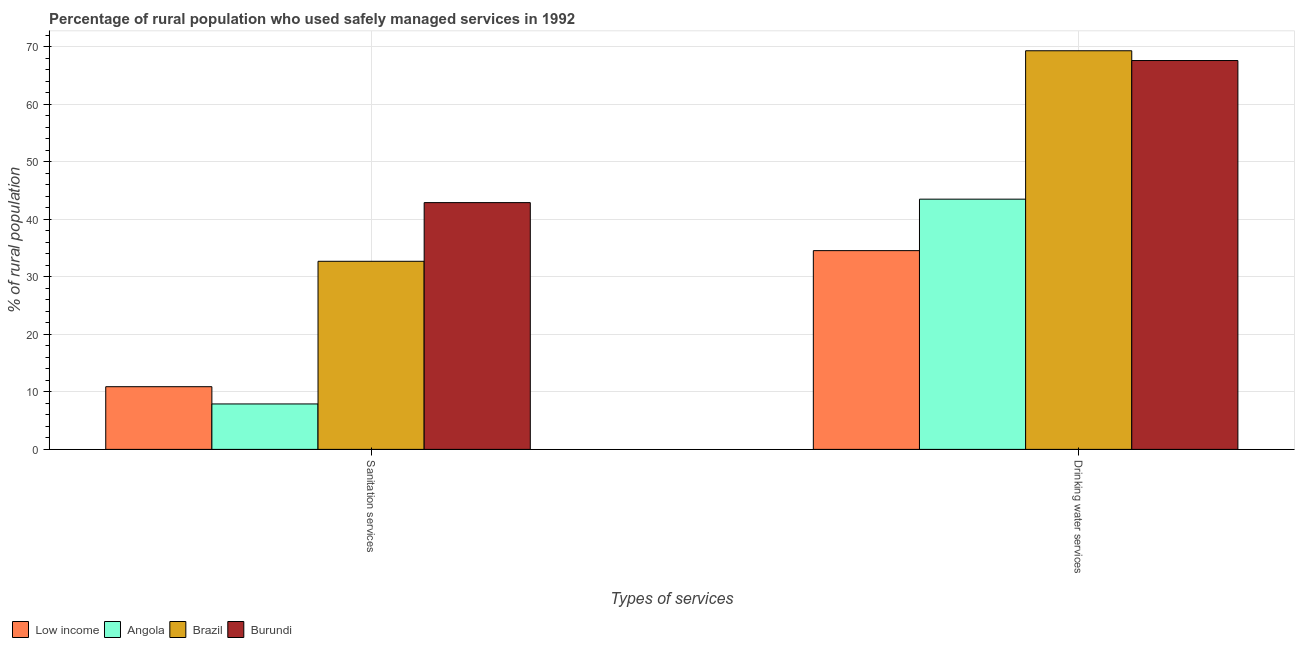How many groups of bars are there?
Your answer should be compact. 2. Are the number of bars on each tick of the X-axis equal?
Offer a terse response. Yes. How many bars are there on the 2nd tick from the left?
Your response must be concise. 4. How many bars are there on the 2nd tick from the right?
Provide a succinct answer. 4. What is the label of the 2nd group of bars from the left?
Make the answer very short. Drinking water services. What is the percentage of rural population who used sanitation services in Burundi?
Your answer should be compact. 42.9. Across all countries, what is the maximum percentage of rural population who used sanitation services?
Provide a short and direct response. 42.9. Across all countries, what is the minimum percentage of rural population who used sanitation services?
Your answer should be compact. 7.9. In which country was the percentage of rural population who used drinking water services maximum?
Give a very brief answer. Brazil. What is the total percentage of rural population who used drinking water services in the graph?
Give a very brief answer. 214.95. What is the difference between the percentage of rural population who used sanitation services in Low income and that in Angola?
Your answer should be very brief. 3. What is the difference between the percentage of rural population who used sanitation services in Low income and the percentage of rural population who used drinking water services in Angola?
Provide a short and direct response. -32.6. What is the average percentage of rural population who used sanitation services per country?
Provide a short and direct response. 23.6. What is the difference between the percentage of rural population who used drinking water services and percentage of rural population who used sanitation services in Low income?
Provide a short and direct response. 23.65. In how many countries, is the percentage of rural population who used sanitation services greater than 48 %?
Keep it short and to the point. 0. What is the ratio of the percentage of rural population who used drinking water services in Low income to that in Burundi?
Keep it short and to the point. 0.51. What does the 2nd bar from the left in Drinking water services represents?
Ensure brevity in your answer.  Angola. What does the 3rd bar from the right in Sanitation services represents?
Your answer should be very brief. Angola. Does the graph contain any zero values?
Make the answer very short. No. Does the graph contain grids?
Make the answer very short. Yes. Where does the legend appear in the graph?
Provide a succinct answer. Bottom left. What is the title of the graph?
Offer a terse response. Percentage of rural population who used safely managed services in 1992. Does "Venezuela" appear as one of the legend labels in the graph?
Your answer should be very brief. No. What is the label or title of the X-axis?
Ensure brevity in your answer.  Types of services. What is the label or title of the Y-axis?
Provide a succinct answer. % of rural population. What is the % of rural population of Low income in Sanitation services?
Offer a terse response. 10.9. What is the % of rural population in Brazil in Sanitation services?
Provide a succinct answer. 32.7. What is the % of rural population of Burundi in Sanitation services?
Provide a succinct answer. 42.9. What is the % of rural population in Low income in Drinking water services?
Your response must be concise. 34.55. What is the % of rural population of Angola in Drinking water services?
Keep it short and to the point. 43.5. What is the % of rural population of Brazil in Drinking water services?
Offer a very short reply. 69.3. What is the % of rural population of Burundi in Drinking water services?
Make the answer very short. 67.6. Across all Types of services, what is the maximum % of rural population of Low income?
Give a very brief answer. 34.55. Across all Types of services, what is the maximum % of rural population in Angola?
Ensure brevity in your answer.  43.5. Across all Types of services, what is the maximum % of rural population of Brazil?
Offer a very short reply. 69.3. Across all Types of services, what is the maximum % of rural population of Burundi?
Your response must be concise. 67.6. Across all Types of services, what is the minimum % of rural population in Low income?
Give a very brief answer. 10.9. Across all Types of services, what is the minimum % of rural population of Angola?
Ensure brevity in your answer.  7.9. Across all Types of services, what is the minimum % of rural population of Brazil?
Provide a short and direct response. 32.7. Across all Types of services, what is the minimum % of rural population in Burundi?
Provide a short and direct response. 42.9. What is the total % of rural population of Low income in the graph?
Keep it short and to the point. 45.45. What is the total % of rural population of Angola in the graph?
Ensure brevity in your answer.  51.4. What is the total % of rural population in Brazil in the graph?
Offer a very short reply. 102. What is the total % of rural population of Burundi in the graph?
Provide a short and direct response. 110.5. What is the difference between the % of rural population of Low income in Sanitation services and that in Drinking water services?
Your answer should be compact. -23.65. What is the difference between the % of rural population in Angola in Sanitation services and that in Drinking water services?
Provide a succinct answer. -35.6. What is the difference between the % of rural population of Brazil in Sanitation services and that in Drinking water services?
Your response must be concise. -36.6. What is the difference between the % of rural population in Burundi in Sanitation services and that in Drinking water services?
Offer a very short reply. -24.7. What is the difference between the % of rural population in Low income in Sanitation services and the % of rural population in Angola in Drinking water services?
Keep it short and to the point. -32.6. What is the difference between the % of rural population in Low income in Sanitation services and the % of rural population in Brazil in Drinking water services?
Provide a succinct answer. -58.4. What is the difference between the % of rural population in Low income in Sanitation services and the % of rural population in Burundi in Drinking water services?
Your answer should be compact. -56.7. What is the difference between the % of rural population in Angola in Sanitation services and the % of rural population in Brazil in Drinking water services?
Your answer should be compact. -61.4. What is the difference between the % of rural population of Angola in Sanitation services and the % of rural population of Burundi in Drinking water services?
Provide a short and direct response. -59.7. What is the difference between the % of rural population of Brazil in Sanitation services and the % of rural population of Burundi in Drinking water services?
Your answer should be compact. -34.9. What is the average % of rural population of Low income per Types of services?
Make the answer very short. 22.73. What is the average % of rural population in Angola per Types of services?
Ensure brevity in your answer.  25.7. What is the average % of rural population of Brazil per Types of services?
Offer a very short reply. 51. What is the average % of rural population of Burundi per Types of services?
Ensure brevity in your answer.  55.25. What is the difference between the % of rural population of Low income and % of rural population of Angola in Sanitation services?
Your response must be concise. 3. What is the difference between the % of rural population of Low income and % of rural population of Brazil in Sanitation services?
Provide a short and direct response. -21.8. What is the difference between the % of rural population of Low income and % of rural population of Burundi in Sanitation services?
Ensure brevity in your answer.  -32. What is the difference between the % of rural population of Angola and % of rural population of Brazil in Sanitation services?
Ensure brevity in your answer.  -24.8. What is the difference between the % of rural population in Angola and % of rural population in Burundi in Sanitation services?
Give a very brief answer. -35. What is the difference between the % of rural population of Low income and % of rural population of Angola in Drinking water services?
Offer a very short reply. -8.95. What is the difference between the % of rural population in Low income and % of rural population in Brazil in Drinking water services?
Offer a terse response. -34.75. What is the difference between the % of rural population in Low income and % of rural population in Burundi in Drinking water services?
Ensure brevity in your answer.  -33.05. What is the difference between the % of rural population in Angola and % of rural population in Brazil in Drinking water services?
Offer a very short reply. -25.8. What is the difference between the % of rural population in Angola and % of rural population in Burundi in Drinking water services?
Provide a succinct answer. -24.1. What is the ratio of the % of rural population of Low income in Sanitation services to that in Drinking water services?
Make the answer very short. 0.32. What is the ratio of the % of rural population in Angola in Sanitation services to that in Drinking water services?
Provide a succinct answer. 0.18. What is the ratio of the % of rural population of Brazil in Sanitation services to that in Drinking water services?
Make the answer very short. 0.47. What is the ratio of the % of rural population in Burundi in Sanitation services to that in Drinking water services?
Provide a short and direct response. 0.63. What is the difference between the highest and the second highest % of rural population of Low income?
Your response must be concise. 23.65. What is the difference between the highest and the second highest % of rural population of Angola?
Offer a terse response. 35.6. What is the difference between the highest and the second highest % of rural population in Brazil?
Ensure brevity in your answer.  36.6. What is the difference between the highest and the second highest % of rural population in Burundi?
Offer a very short reply. 24.7. What is the difference between the highest and the lowest % of rural population in Low income?
Offer a terse response. 23.65. What is the difference between the highest and the lowest % of rural population in Angola?
Your answer should be compact. 35.6. What is the difference between the highest and the lowest % of rural population in Brazil?
Offer a terse response. 36.6. What is the difference between the highest and the lowest % of rural population in Burundi?
Offer a very short reply. 24.7. 